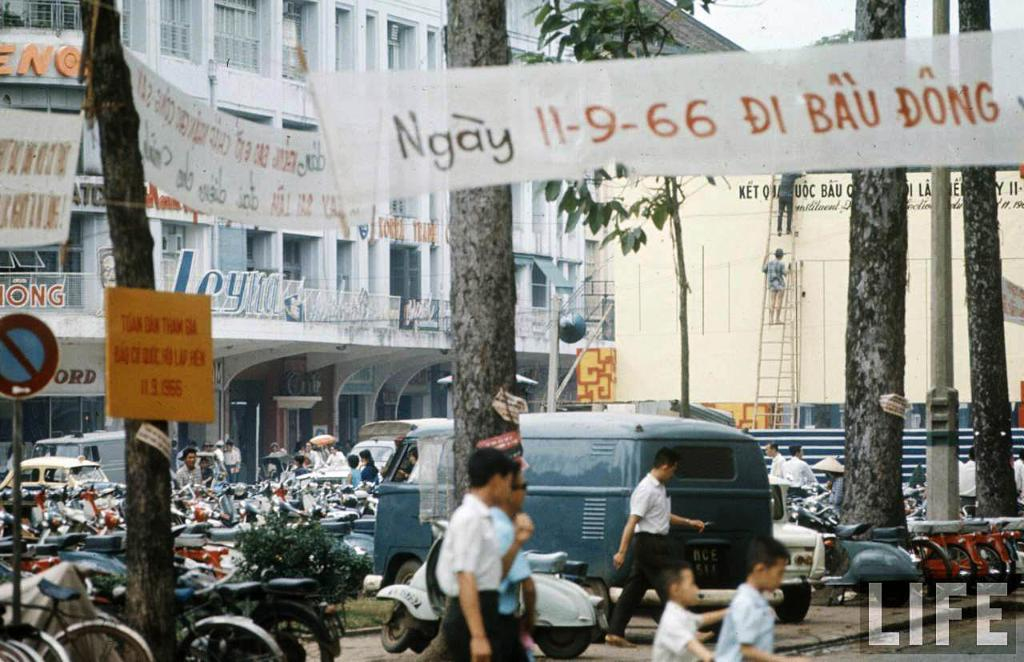What can be seen at the bottom of the image? There are people, bikes, a van, and cars at the bottom of the image. What is present in the background of the image? There are buildings and trees in the background of the image. What additional items can be seen in the image? Banners and boards are present in the image. Where is a specific sign board located in the image? There is a sign board on the left side of the image. Can you touch the town in the image? There is no town present in the image, and therefore it cannot be touched. How does the road in the image connect to the town? There is no road or town present in the image, so this question cannot be answered. 